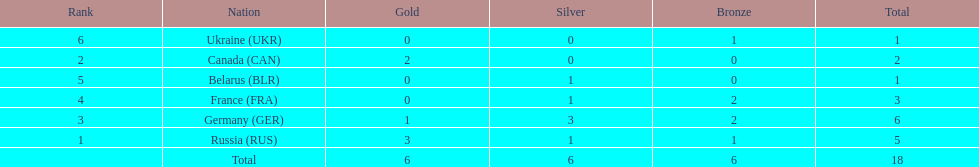How many silver medals did belarus win? 1. 